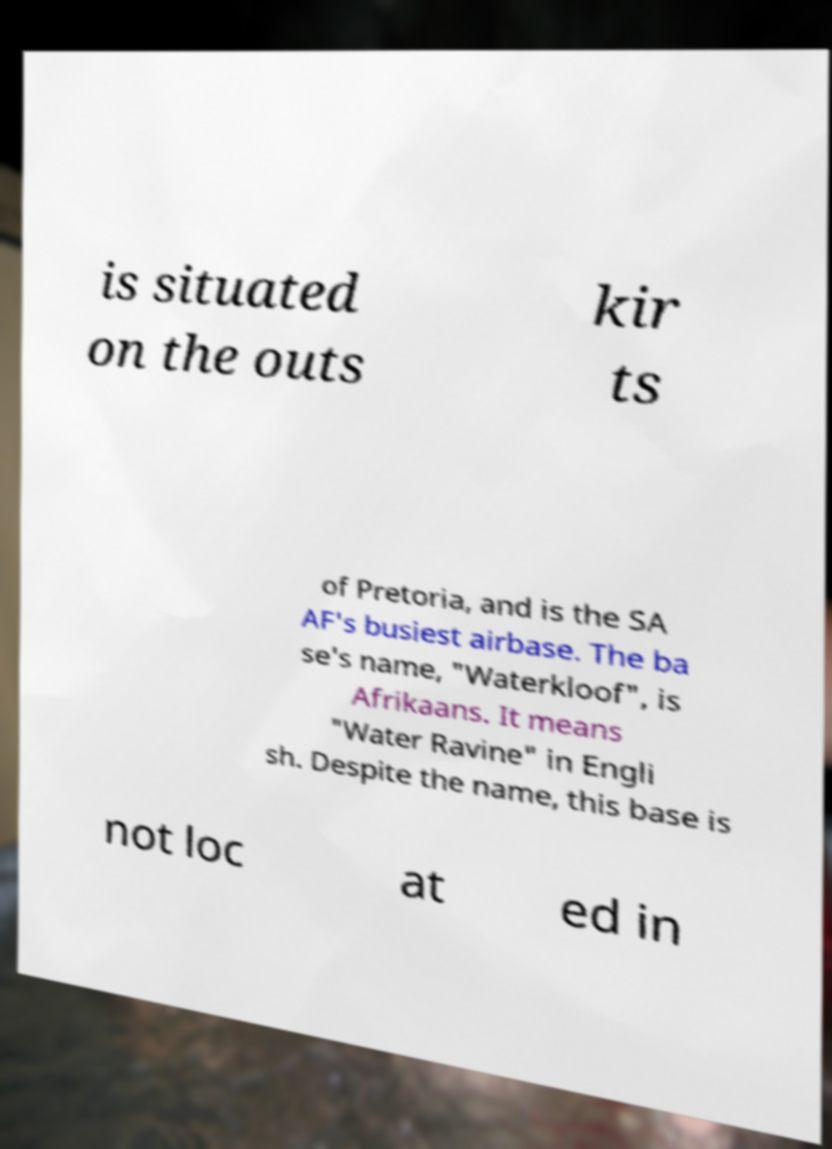What messages or text are displayed in this image? I need them in a readable, typed format. is situated on the outs kir ts of Pretoria, and is the SA AF's busiest airbase. The ba se's name, "Waterkloof", is Afrikaans. It means "Water Ravine" in Engli sh. Despite the name, this base is not loc at ed in 